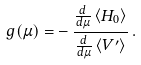Convert formula to latex. <formula><loc_0><loc_0><loc_500><loc_500>g ( \mu ) = - \, \frac { \frac { d } { d \mu } \left < H _ { 0 } \right > } { \frac { d } { d \mu } \left < V ^ { \prime } \right > } \, .</formula> 